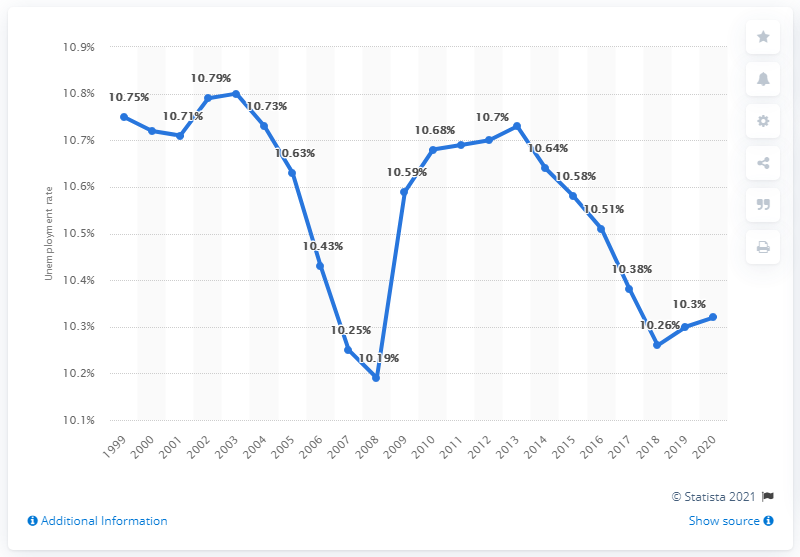Indicate a few pertinent items in this graphic. The unemployment rate in Djibouti in 2020 was 10.32%. 